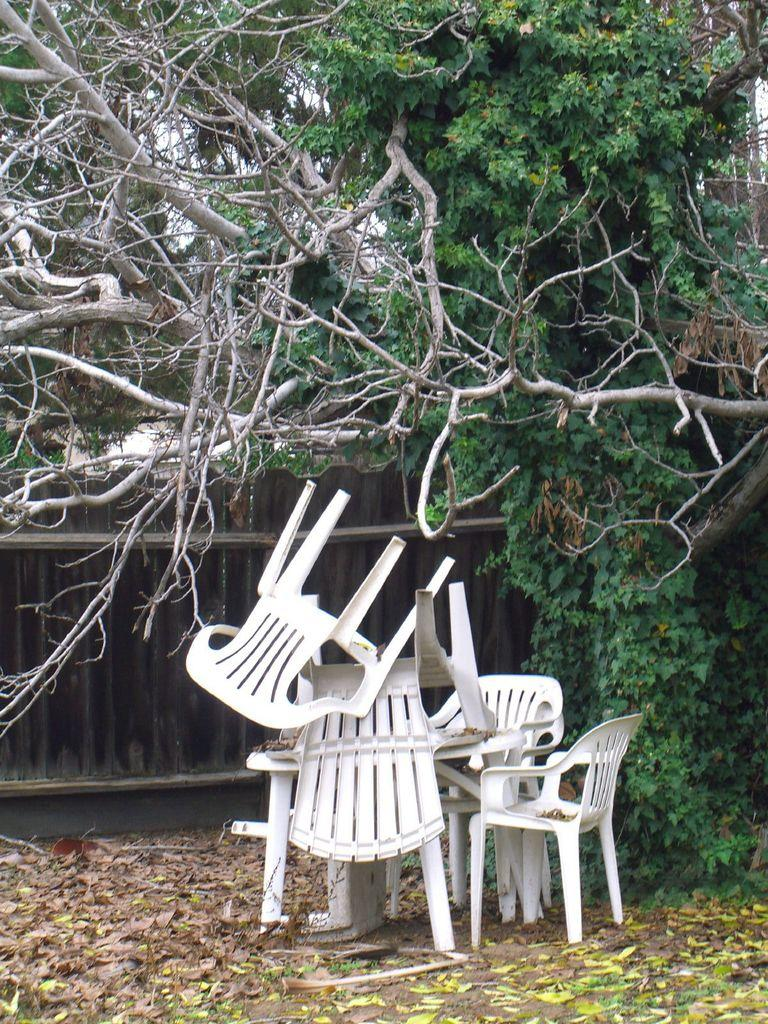What objects are located in the center of the image? There are chairs in the center of the image. What can be seen in the background of the image? There is a gate and trees in the background of the image. What type of vegetation is visible at the bottom of the image? Leaves are visible at the bottom of the image. What type of nerve can be seen in the image? There is no nerve present in the image. Is there an oven visible in the image? There is no oven present in the image. 